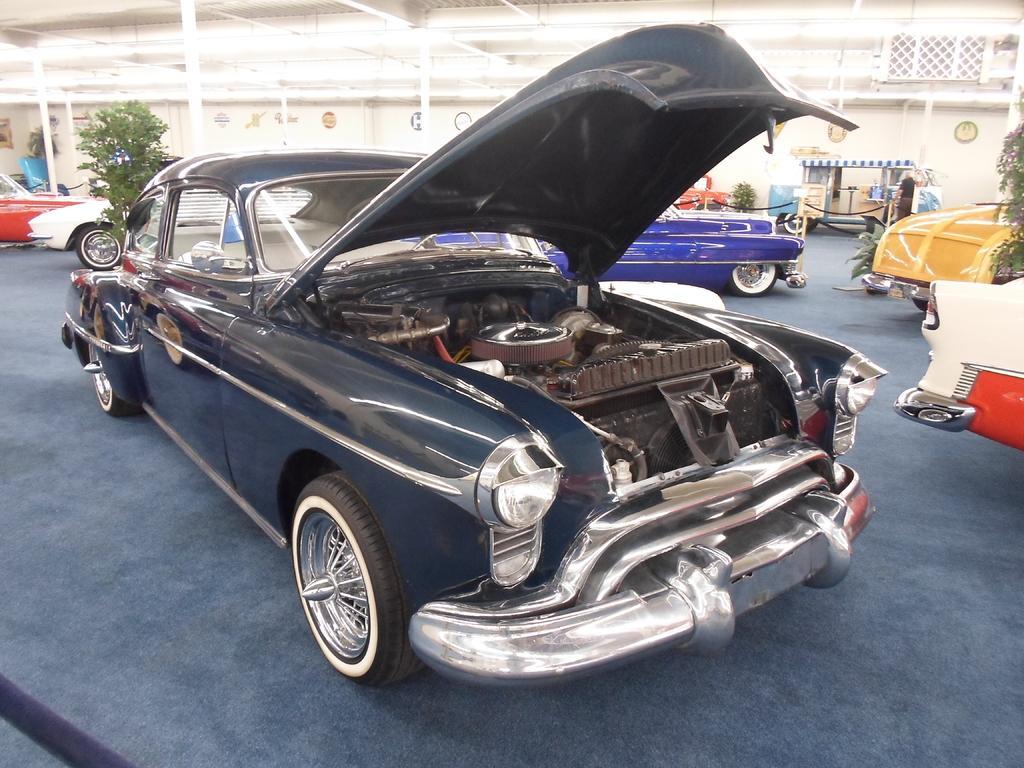Could you give a brief overview of what you see in this image? In this image I see number of cars which are colorful and I see the path which is of blue in color and I see number of plants. In the background I see the wall. 